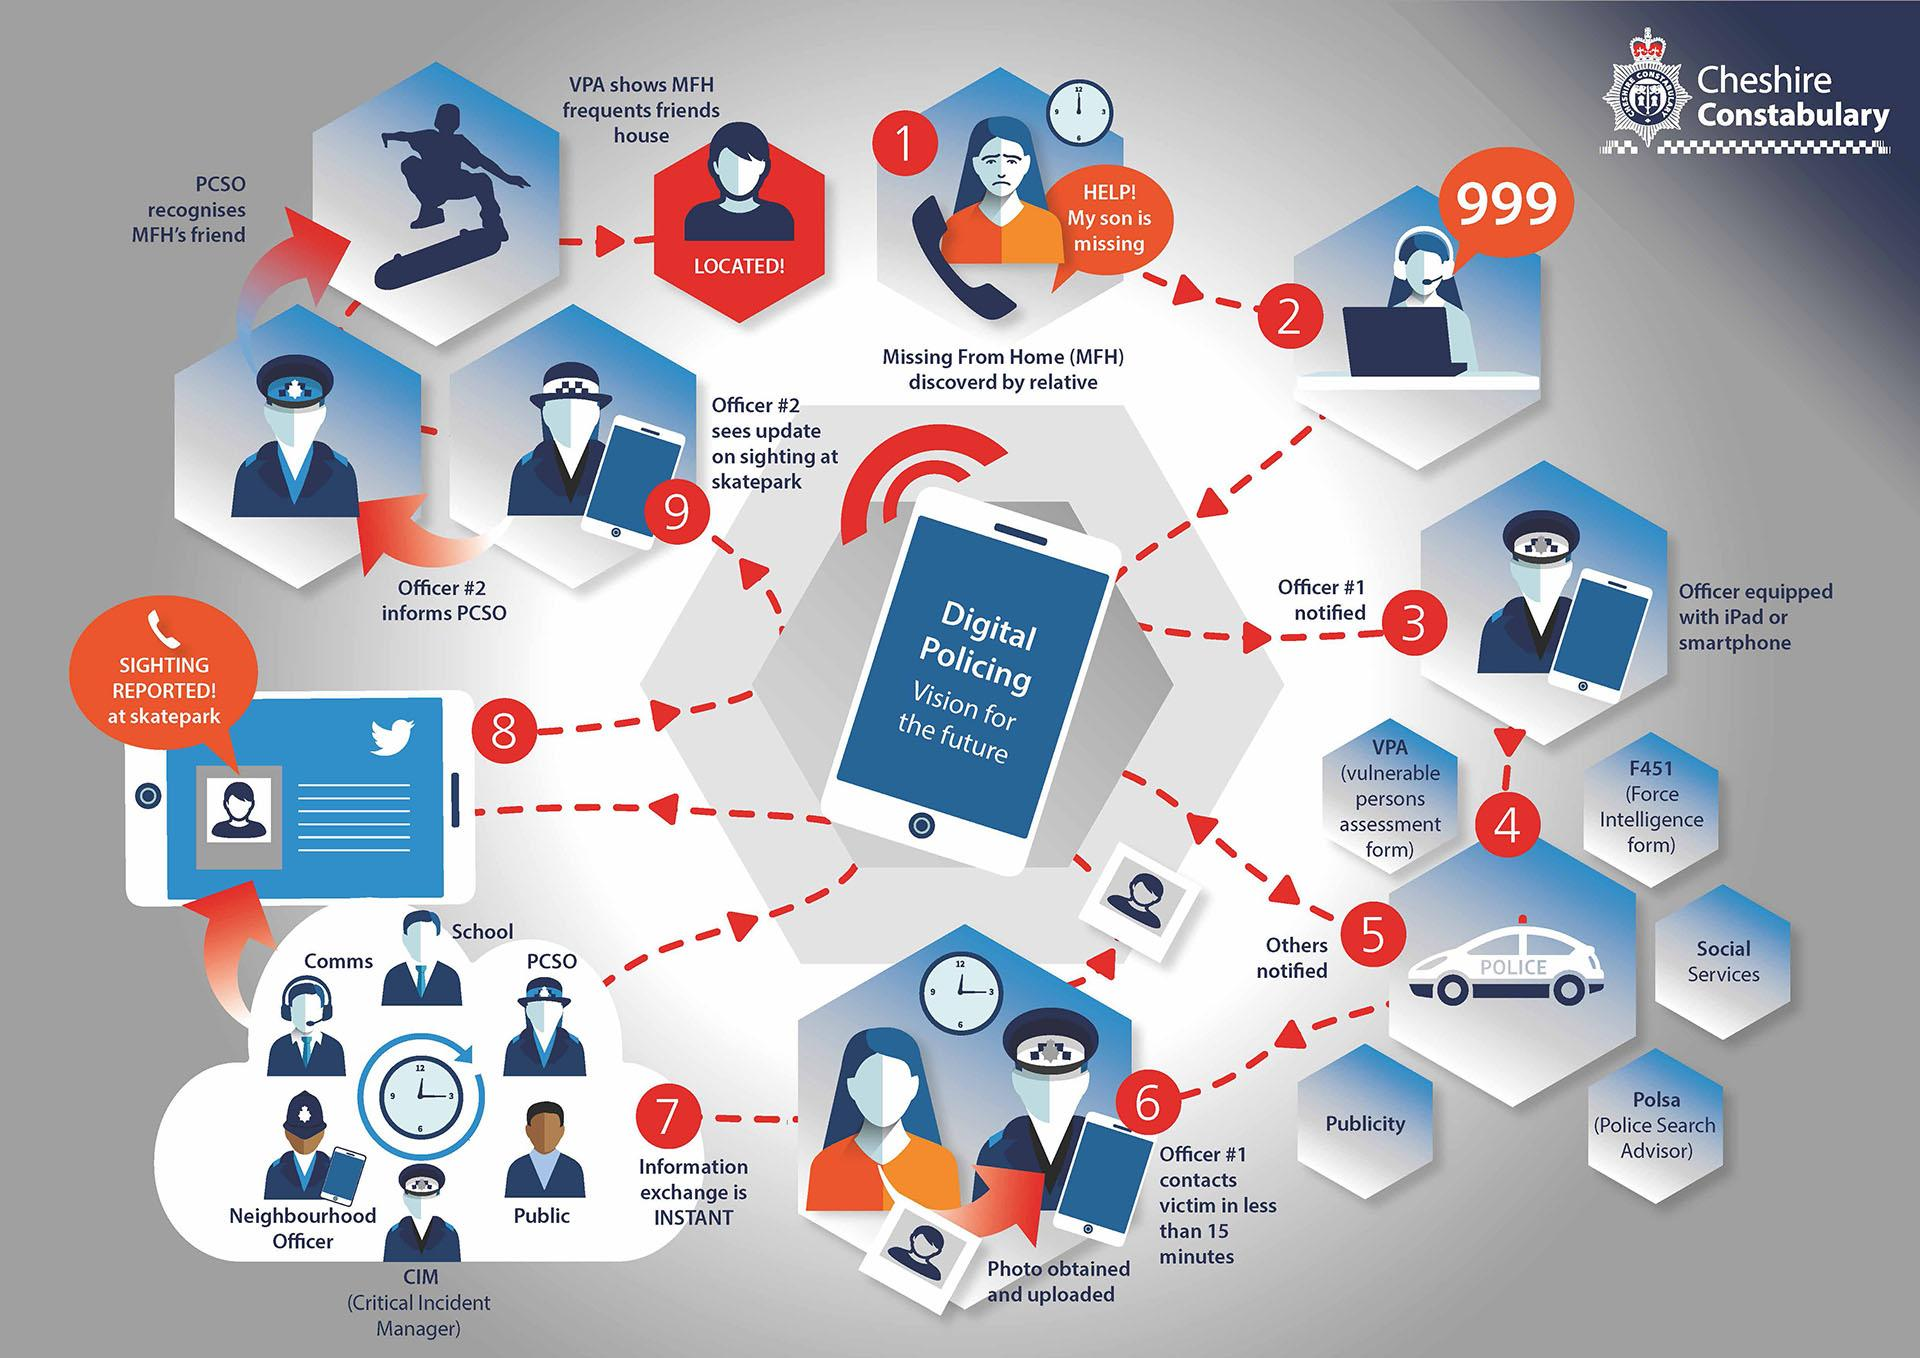List a handful of essential elements in this visual. Six people are involved in the information exchange process. The discovery of the victim has been made in Step 9. The missing from home case was first reported on 999. 